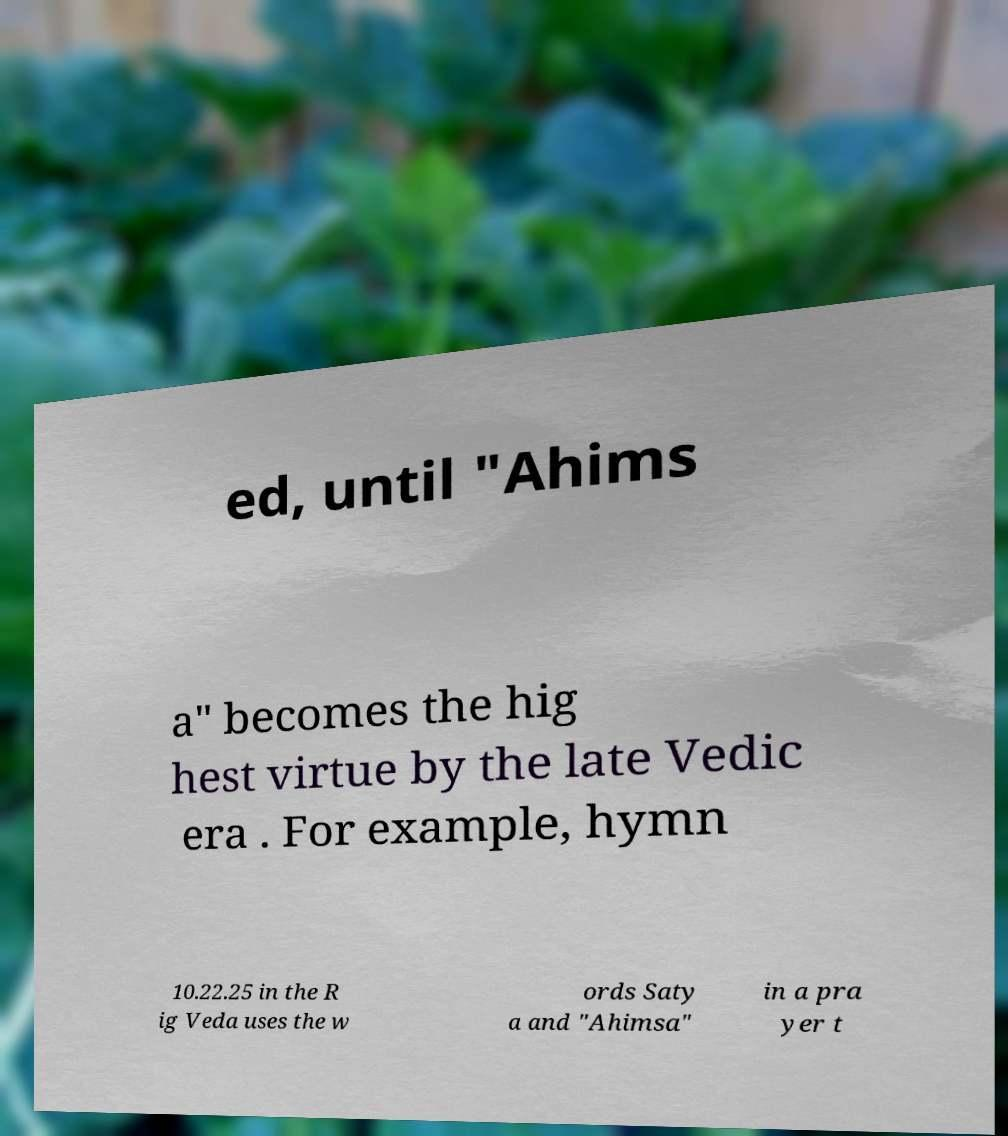Could you assist in decoding the text presented in this image and type it out clearly? ed, until "Ahims a" becomes the hig hest virtue by the late Vedic era . For example, hymn 10.22.25 in the R ig Veda uses the w ords Saty a and "Ahimsa" in a pra yer t 